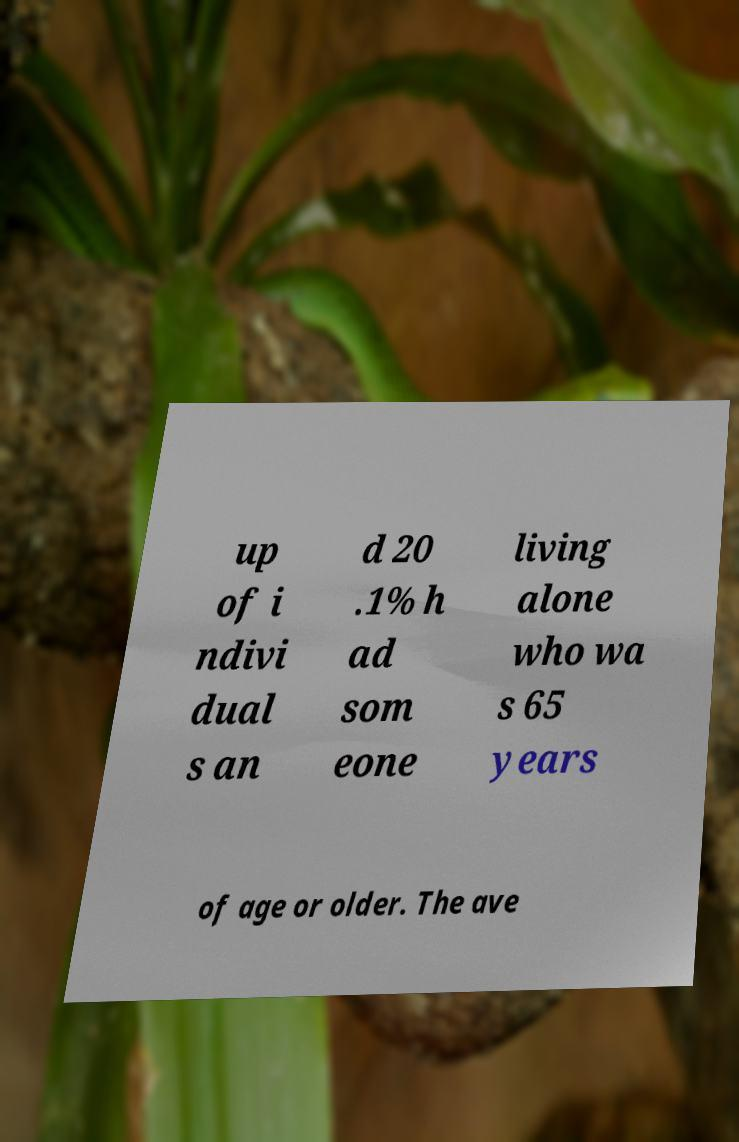Can you accurately transcribe the text from the provided image for me? up of i ndivi dual s an d 20 .1% h ad som eone living alone who wa s 65 years of age or older. The ave 